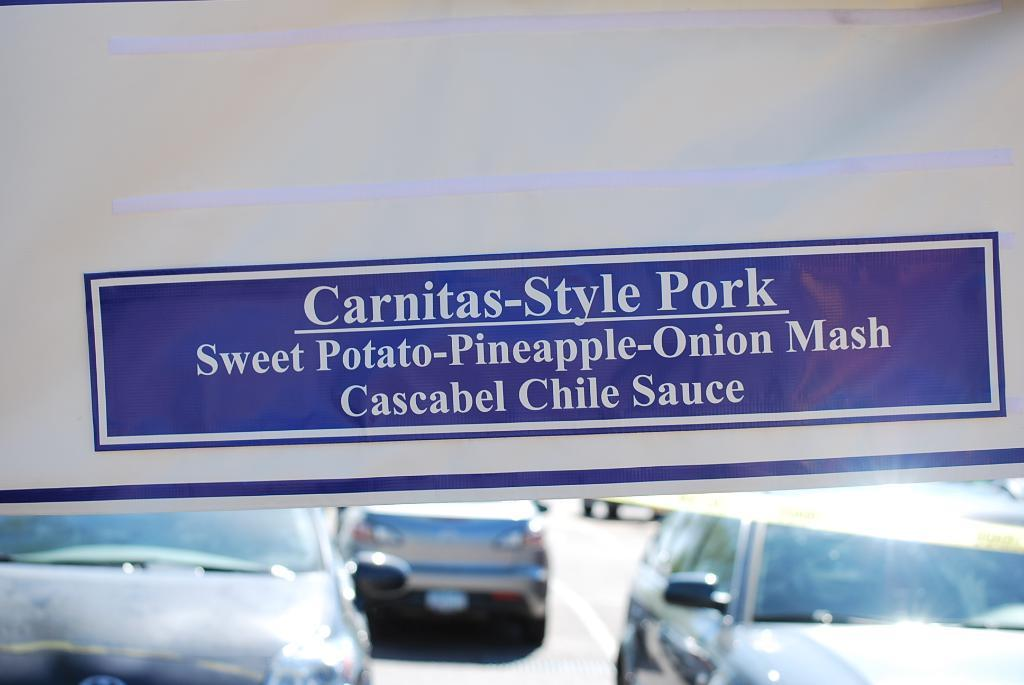What colors are used on the banner in the image? The banner in the image is white and blue. What can be seen on the banner? Something is written on the banner. What else is visible in the image besides the banner? There are vehicles visible on the road in the image. What type of cabbage is hanging from the banner in the image? There is no cabbage present in the image. What kind of apparatus is used to ring the bells in the image? There are no bells or any apparatus to ring them in the image. 